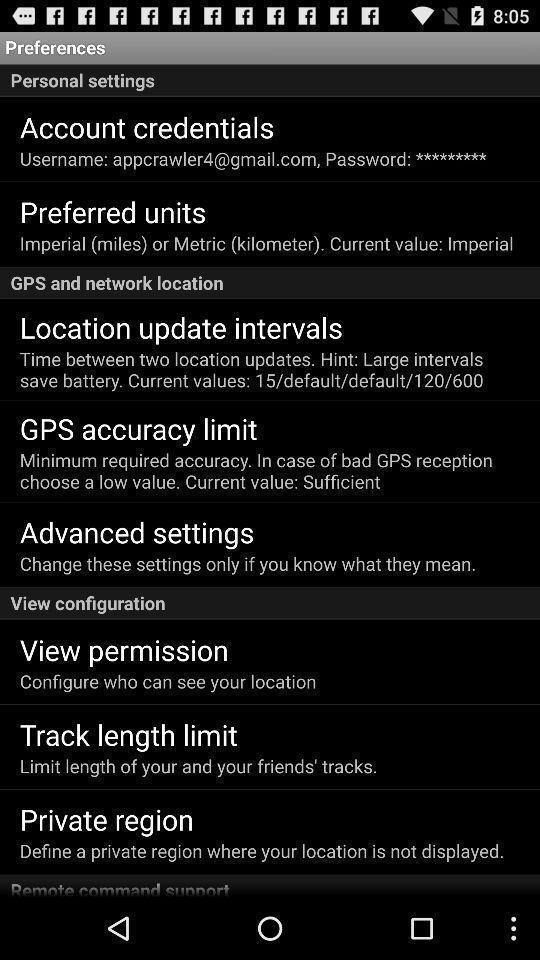Describe this image in words. Screen displaying list of options under settings. 